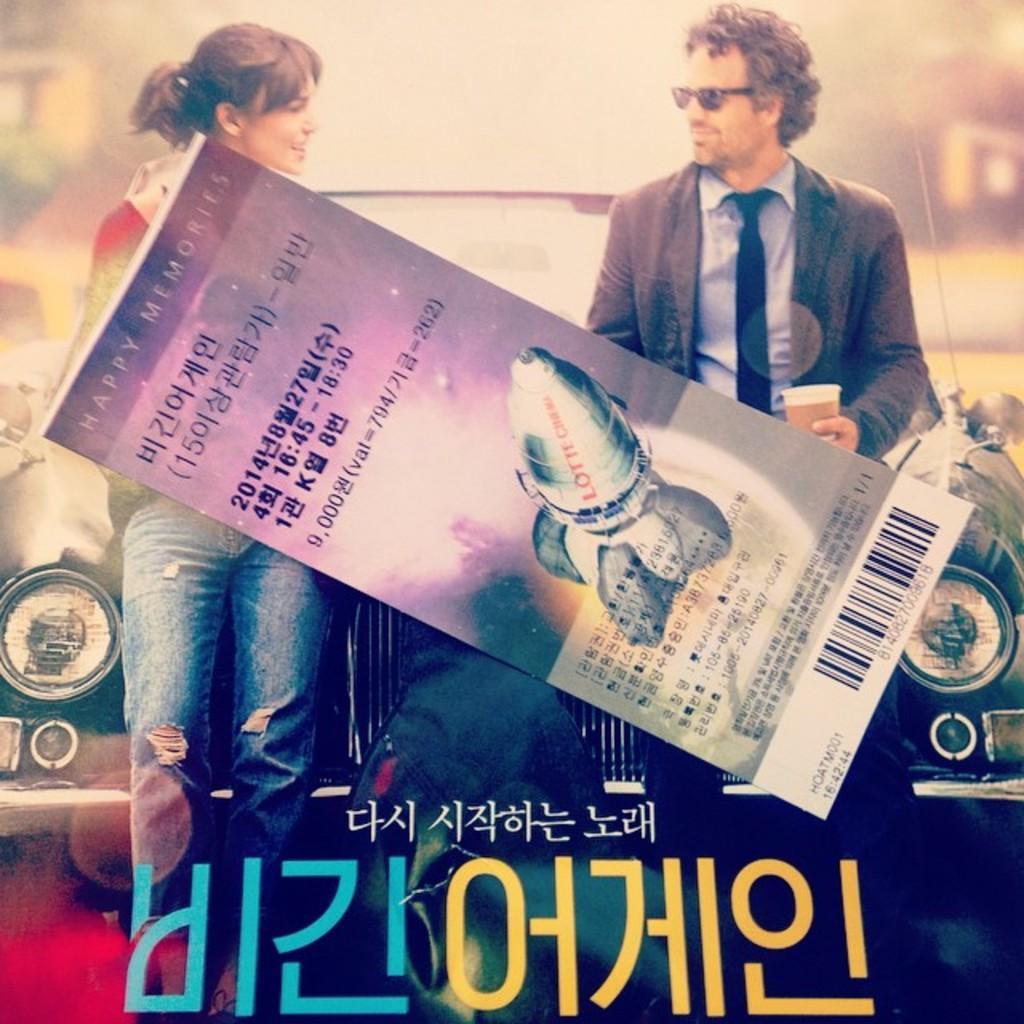Describe this image in one or two sentences. This is an edited image, We can see there are two persons standing and holding a poster, and there is a car in the background. There is some text written at the bottom of this image. 